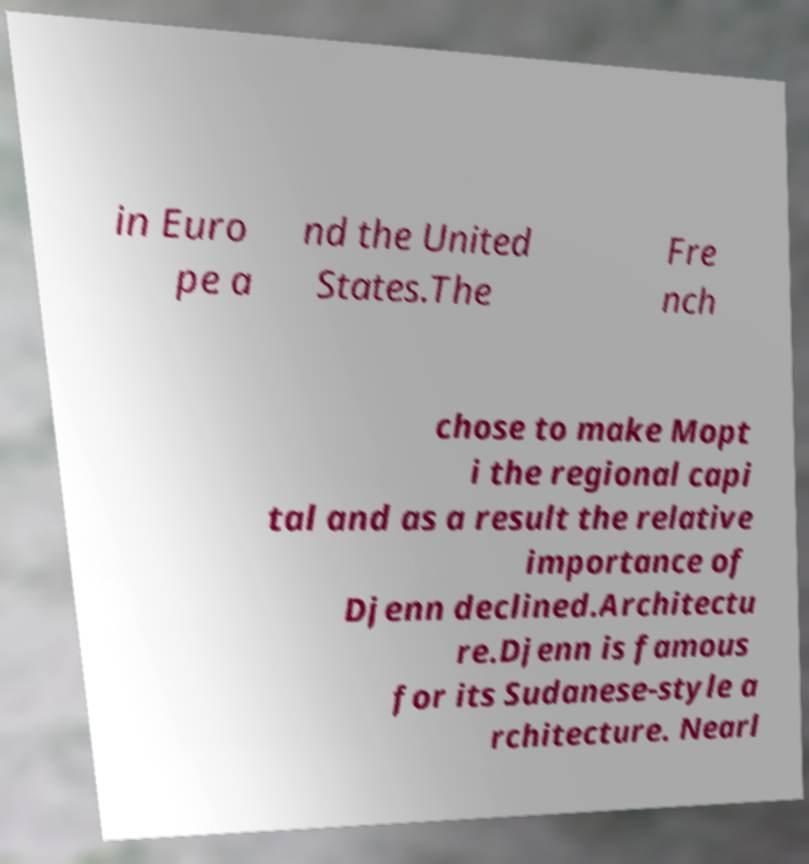Can you read and provide the text displayed in the image?This photo seems to have some interesting text. Can you extract and type it out for me? in Euro pe a nd the United States.The Fre nch chose to make Mopt i the regional capi tal and as a result the relative importance of Djenn declined.Architectu re.Djenn is famous for its Sudanese-style a rchitecture. Nearl 